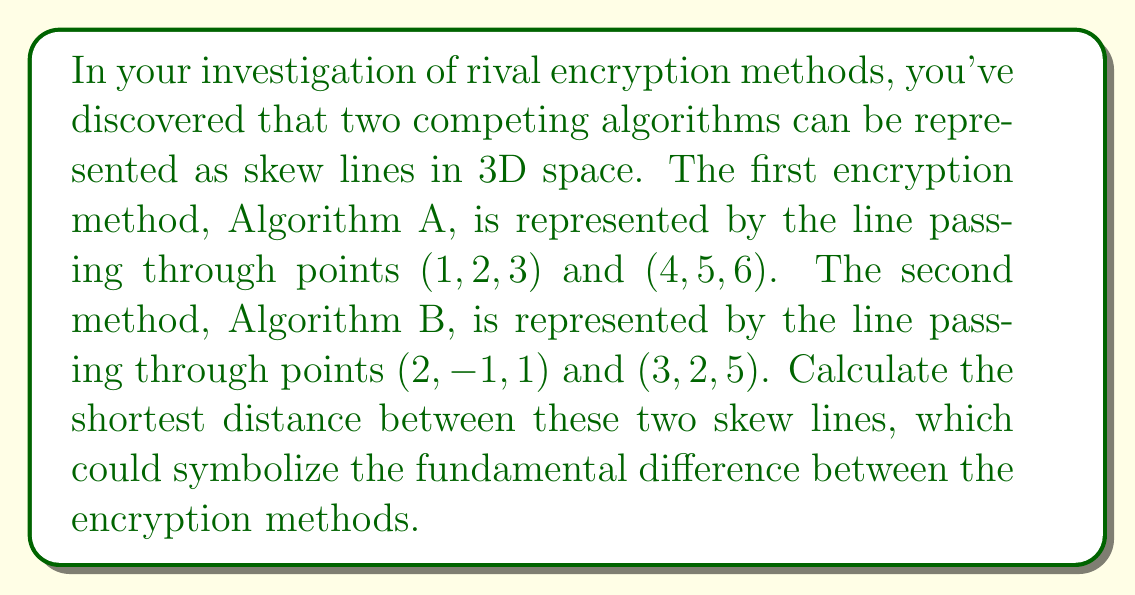Could you help me with this problem? To find the shortest distance between two skew lines, we can follow these steps:

1) First, let's define direction vectors for each line:
   For Algorithm A: $\vec{a} = (4-1, 5-2, 6-3) = (3, 3, 3)$
   For Algorithm B: $\vec{b} = (3-2, 2-(-1), 5-1) = (1, 3, 4)$

2) Now, we calculate the cross product of these direction vectors:
   $\vec{n} = \vec{a} \times \vec{b} = \begin{vmatrix} 
   i & j & k \\
   3 & 3 & 3 \\
   1 & 3 & 4
   \end{vmatrix} = (3\cdot4 - 3\cdot3)i - (3\cdot1 - 3\cdot4)j + (3\cdot3 - 3\cdot1)k = 3i + 9j + 6k$

3) We need a vector connecting a point on one line to a point on the other. Let's use the given points:
   $\vec{c} = (2-1, -1-2, 1-3) = (1, -3, -2)$

4) The shortest distance is given by the formula:
   $d = \frac{|\vec{c} \cdot \vec{n}|}{|\vec{n}|}$

5) Let's calculate the dot product in the numerator:
   $\vec{c} \cdot \vec{n} = 1(3) + (-3)(9) + (-2)(6) = 3 - 27 - 12 = -36$

6) Now, let's calculate the magnitude of $\vec{n}$ for the denominator:
   $|\vec{n}| = \sqrt{3^2 + 9^2 + 6^2} = \sqrt{126}$

7) Putting it all together:
   $d = \frac{|-36|}{\sqrt{126}} = \frac{36}{\sqrt{126}} = \frac{36\sqrt{126}}{126} = \frac{18\sqrt{14}}{7}$
Answer: The shortest distance between the two skew lines representing the rival encryption methods is $\frac{18\sqrt{14}}{7}$ units. 